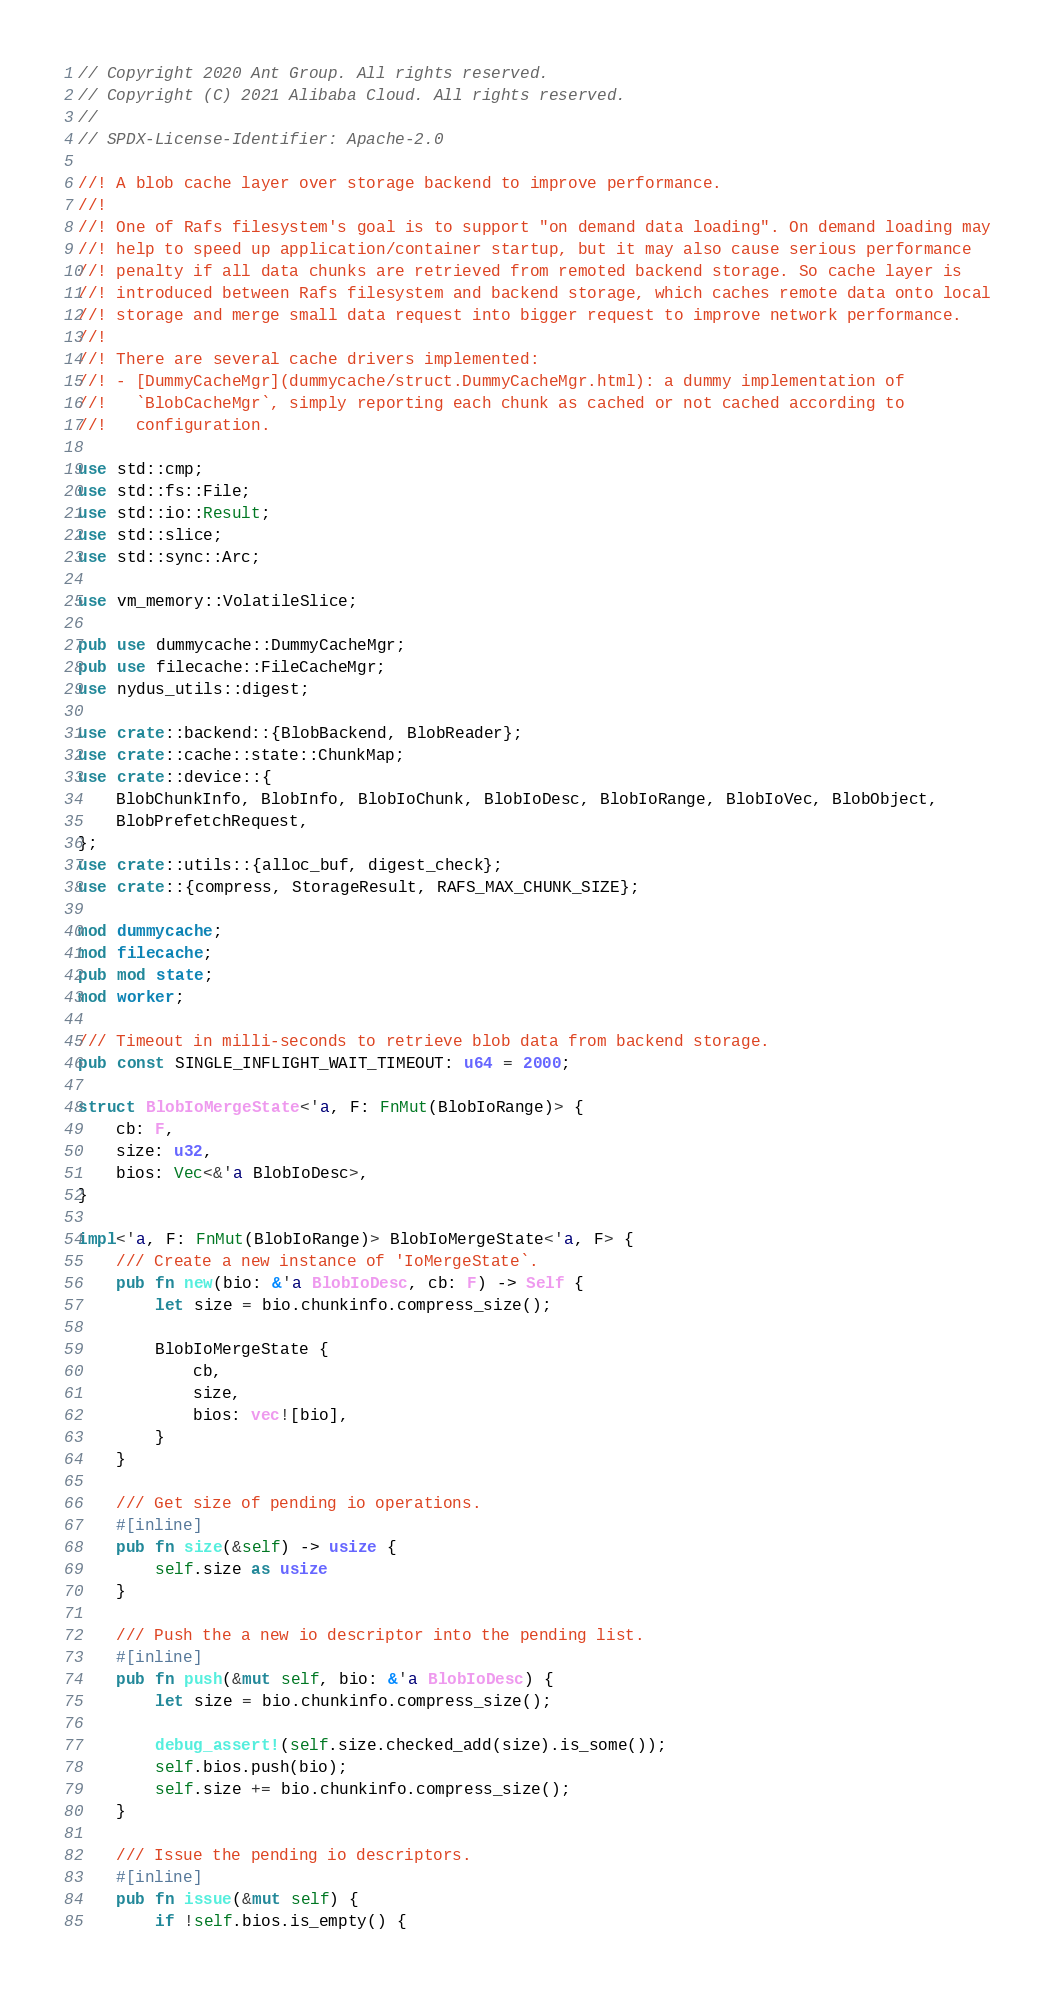<code> <loc_0><loc_0><loc_500><loc_500><_Rust_>// Copyright 2020 Ant Group. All rights reserved.
// Copyright (C) 2021 Alibaba Cloud. All rights reserved.
//
// SPDX-License-Identifier: Apache-2.0

//! A blob cache layer over storage backend to improve performance.
//!
//! One of Rafs filesystem's goal is to support "on demand data loading". On demand loading may
//! help to speed up application/container startup, but it may also cause serious performance
//! penalty if all data chunks are retrieved from remoted backend storage. So cache layer is
//! introduced between Rafs filesystem and backend storage, which caches remote data onto local
//! storage and merge small data request into bigger request to improve network performance.
//!
//! There are several cache drivers implemented:
//! - [DummyCacheMgr](dummycache/struct.DummyCacheMgr.html): a dummy implementation of
//!   `BlobCacheMgr`, simply reporting each chunk as cached or not cached according to
//!   configuration.

use std::cmp;
use std::fs::File;
use std::io::Result;
use std::slice;
use std::sync::Arc;

use vm_memory::VolatileSlice;

pub use dummycache::DummyCacheMgr;
pub use filecache::FileCacheMgr;
use nydus_utils::digest;

use crate::backend::{BlobBackend, BlobReader};
use crate::cache::state::ChunkMap;
use crate::device::{
    BlobChunkInfo, BlobInfo, BlobIoChunk, BlobIoDesc, BlobIoRange, BlobIoVec, BlobObject,
    BlobPrefetchRequest,
};
use crate::utils::{alloc_buf, digest_check};
use crate::{compress, StorageResult, RAFS_MAX_CHUNK_SIZE};

mod dummycache;
mod filecache;
pub mod state;
mod worker;

/// Timeout in milli-seconds to retrieve blob data from backend storage.
pub const SINGLE_INFLIGHT_WAIT_TIMEOUT: u64 = 2000;

struct BlobIoMergeState<'a, F: FnMut(BlobIoRange)> {
    cb: F,
    size: u32,
    bios: Vec<&'a BlobIoDesc>,
}

impl<'a, F: FnMut(BlobIoRange)> BlobIoMergeState<'a, F> {
    /// Create a new instance of 'IoMergeState`.
    pub fn new(bio: &'a BlobIoDesc, cb: F) -> Self {
        let size = bio.chunkinfo.compress_size();

        BlobIoMergeState {
            cb,
            size,
            bios: vec![bio],
        }
    }

    /// Get size of pending io operations.
    #[inline]
    pub fn size(&self) -> usize {
        self.size as usize
    }

    /// Push the a new io descriptor into the pending list.
    #[inline]
    pub fn push(&mut self, bio: &'a BlobIoDesc) {
        let size = bio.chunkinfo.compress_size();

        debug_assert!(self.size.checked_add(size).is_some());
        self.bios.push(bio);
        self.size += bio.chunkinfo.compress_size();
    }

    /// Issue the pending io descriptors.
    #[inline]
    pub fn issue(&mut self) {
        if !self.bios.is_empty() {</code> 